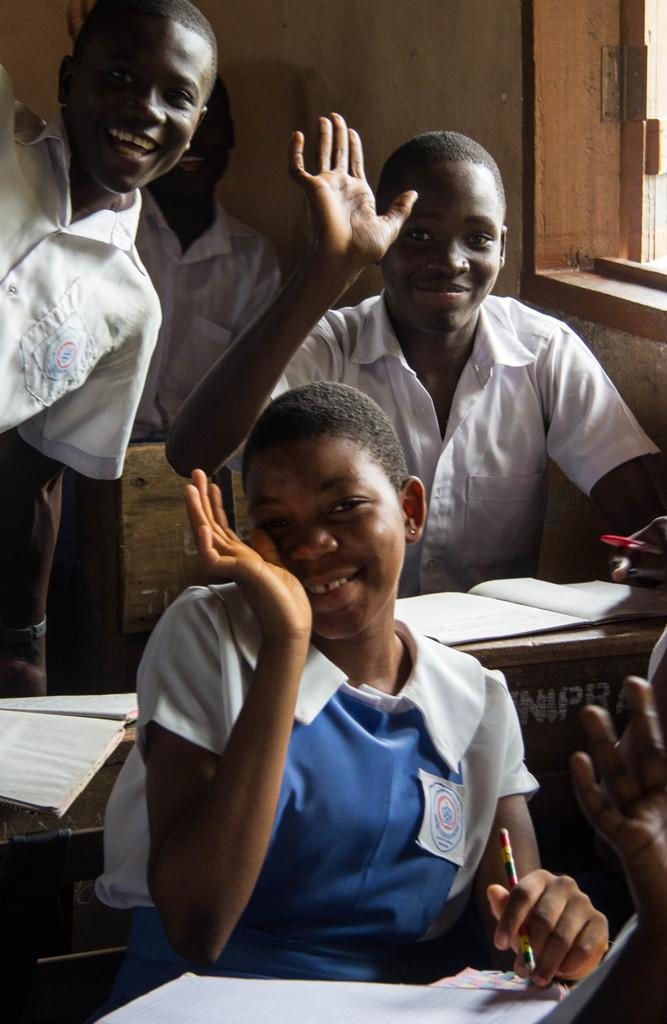What are the persons in the image doing while sitting on the bench? The persons are waving their hands in the image. What objects are the persons holding? The persons are holding a pencil in the image. What might the persons be using the pencil for? The persons might be using the pencil for writing or drawing, as there are books in front of them. What can be seen in the background of the image? There is a wall and a window in the background of the image. What type of motion can be seen in the cart in the image? There is no cart present in the image; it features persons sitting on a bench. What is the lead content of the pencil held by the persons? The lead content of the pencil cannot be determined from the image, as it does not provide information about the pencil's composition. 